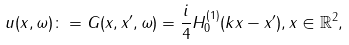Convert formula to latex. <formula><loc_0><loc_0><loc_500><loc_500>u ( x , \omega ) \colon = G ( x , x ^ { \prime } , \omega ) = \frac { i } { 4 } H _ { 0 } ^ { ( 1 ) } ( k \| x - x ^ { \prime } \| ) , x \in \mathbb { R } ^ { 2 } ,</formula> 